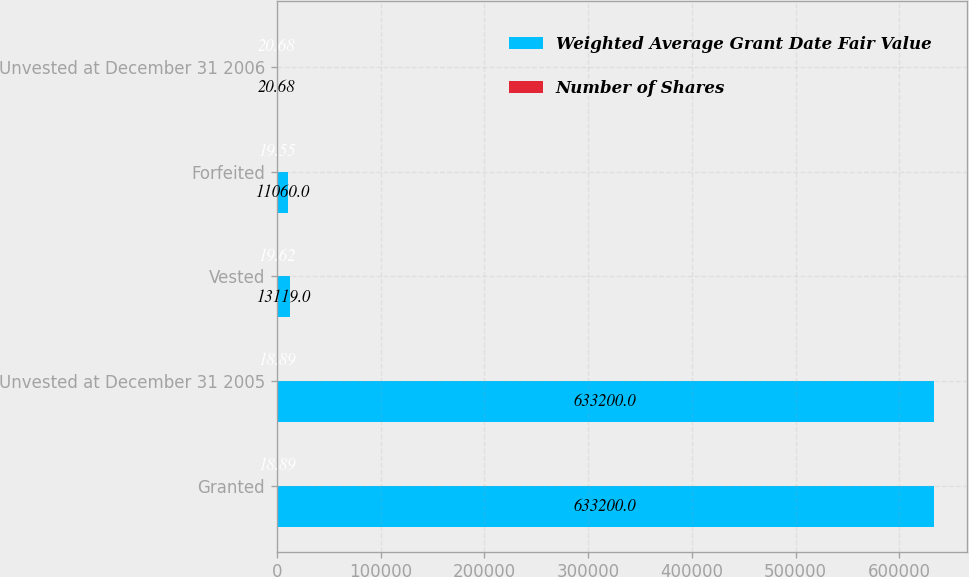<chart> <loc_0><loc_0><loc_500><loc_500><stacked_bar_chart><ecel><fcel>Granted<fcel>Unvested at December 31 2005<fcel>Vested<fcel>Forfeited<fcel>Unvested at December 31 2006<nl><fcel>Weighted Average Grant Date Fair Value<fcel>633200<fcel>633200<fcel>13119<fcel>11060<fcel>20.68<nl><fcel>Number of Shares<fcel>18.89<fcel>18.89<fcel>19.62<fcel>19.55<fcel>20.68<nl></chart> 